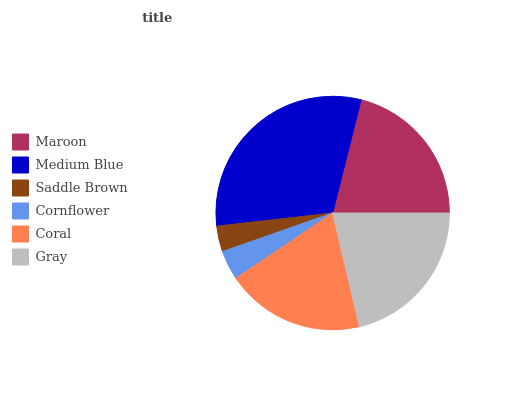Is Saddle Brown the minimum?
Answer yes or no. Yes. Is Medium Blue the maximum?
Answer yes or no. Yes. Is Medium Blue the minimum?
Answer yes or no. No. Is Saddle Brown the maximum?
Answer yes or no. No. Is Medium Blue greater than Saddle Brown?
Answer yes or no. Yes. Is Saddle Brown less than Medium Blue?
Answer yes or no. Yes. Is Saddle Brown greater than Medium Blue?
Answer yes or no. No. Is Medium Blue less than Saddle Brown?
Answer yes or no. No. Is Maroon the high median?
Answer yes or no. Yes. Is Coral the low median?
Answer yes or no. Yes. Is Saddle Brown the high median?
Answer yes or no. No. Is Medium Blue the low median?
Answer yes or no. No. 